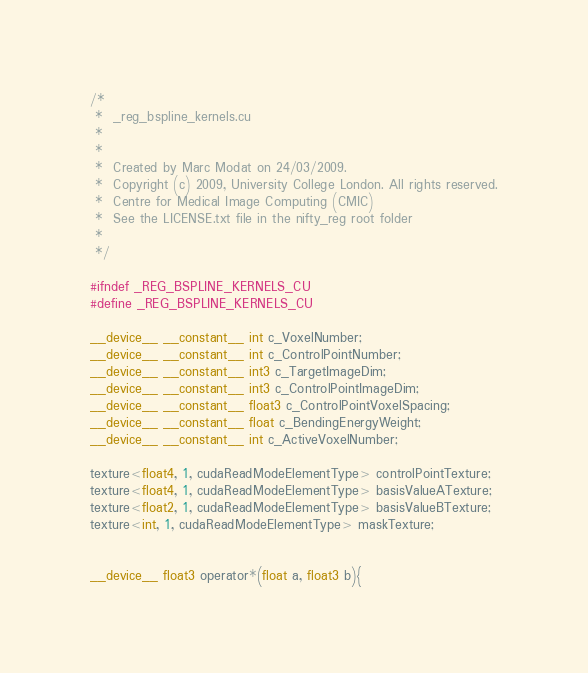Convert code to text. <code><loc_0><loc_0><loc_500><loc_500><_Cuda_>/*
 *  _reg_bspline_kernels.cu
 *
 *
 *  Created by Marc Modat on 24/03/2009.
 *  Copyright (c) 2009, University College London. All rights reserved.
 *  Centre for Medical Image Computing (CMIC)
 *  See the LICENSE.txt file in the nifty_reg root folder
 *
 */

#ifndef _REG_BSPLINE_KERNELS_CU
#define _REG_BSPLINE_KERNELS_CU

__device__ __constant__ int c_VoxelNumber;
__device__ __constant__ int c_ControlPointNumber;
__device__ __constant__ int3 c_TargetImageDim;
__device__ __constant__ int3 c_ControlPointImageDim;
__device__ __constant__ float3 c_ControlPointVoxelSpacing;
__device__ __constant__ float c_BendingEnergyWeight;
__device__ __constant__ int c_ActiveVoxelNumber;

texture<float4, 1, cudaReadModeElementType> controlPointTexture;
texture<float4, 1, cudaReadModeElementType> basisValueATexture;
texture<float2, 1, cudaReadModeElementType> basisValueBTexture;
texture<int, 1, cudaReadModeElementType> maskTexture;


__device__ float3 operator*(float a, float3 b){</code> 